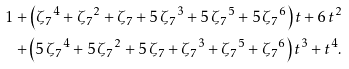<formula> <loc_0><loc_0><loc_500><loc_500>1 + \left ( { \zeta _ { 7 } } ^ { 4 } + { \zeta _ { 7 } } ^ { 2 } + \zeta _ { 7 } + 5 \, { \zeta _ { 7 } } ^ { 3 } + 5 \, { \zeta _ { 7 } } ^ { 5 } + 5 \, { \zeta _ { 7 } } ^ { 6 } \right ) t + 6 \, { t } ^ { 2 } \\ + \left ( 5 \, { \zeta _ { 7 } } ^ { 4 } + 5 \, { \zeta _ { 7 } } ^ { 2 } + 5 \, \zeta _ { 7 } + { \zeta _ { 7 } } ^ { 3 } + { \zeta _ { 7 } } ^ { 5 } + { \zeta _ { 7 } } ^ { 6 } \right ) { t } ^ { 3 } + { t } ^ { 4 } .</formula> 